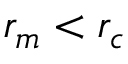<formula> <loc_0><loc_0><loc_500><loc_500>r _ { m } < r _ { c }</formula> 